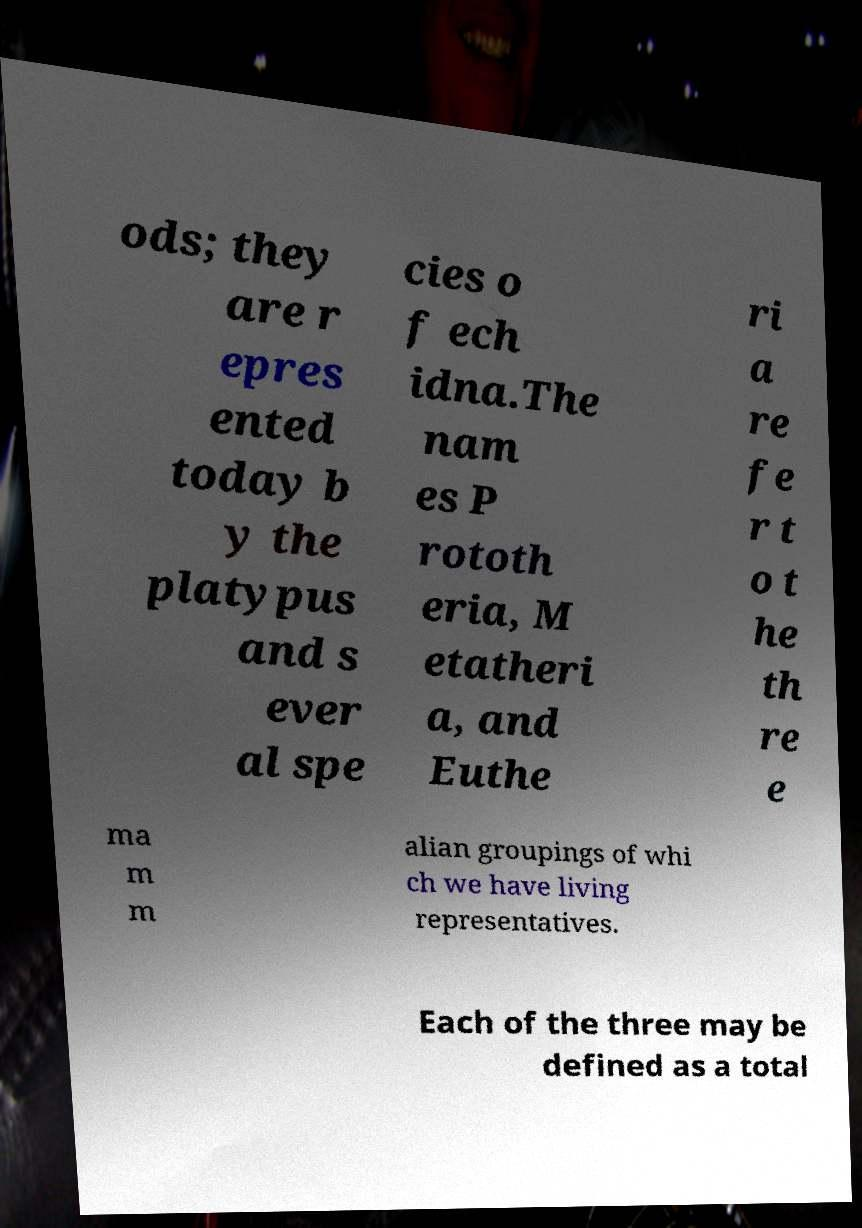Please identify and transcribe the text found in this image. ods; they are r epres ented today b y the platypus and s ever al spe cies o f ech idna.The nam es P rototh eria, M etatheri a, and Euthe ri a re fe r t o t he th re e ma m m alian groupings of whi ch we have living representatives. Each of the three may be defined as a total 